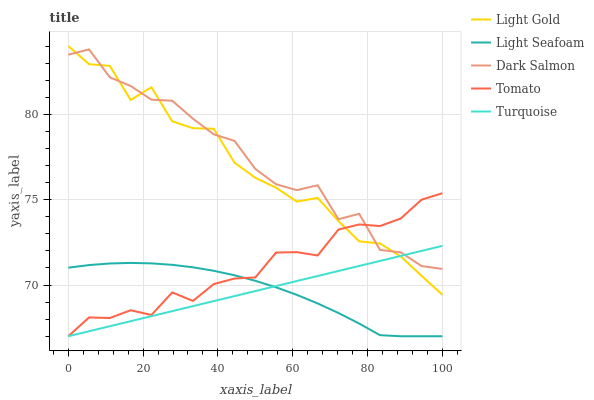Does Light Seafoam have the minimum area under the curve?
Answer yes or no. Yes. Does Dark Salmon have the maximum area under the curve?
Answer yes or no. Yes. Does Turquoise have the minimum area under the curve?
Answer yes or no. No. Does Turquoise have the maximum area under the curve?
Answer yes or no. No. Is Turquoise the smoothest?
Answer yes or no. Yes. Is Dark Salmon the roughest?
Answer yes or no. Yes. Is Light Seafoam the smoothest?
Answer yes or no. No. Is Light Seafoam the roughest?
Answer yes or no. No. Does Tomato have the lowest value?
Answer yes or no. Yes. Does Light Gold have the lowest value?
Answer yes or no. No. Does Light Gold have the highest value?
Answer yes or no. Yes. Does Turquoise have the highest value?
Answer yes or no. No. Is Light Seafoam less than Dark Salmon?
Answer yes or no. Yes. Is Light Gold greater than Light Seafoam?
Answer yes or no. Yes. Does Turquoise intersect Light Seafoam?
Answer yes or no. Yes. Is Turquoise less than Light Seafoam?
Answer yes or no. No. Is Turquoise greater than Light Seafoam?
Answer yes or no. No. Does Light Seafoam intersect Dark Salmon?
Answer yes or no. No. 